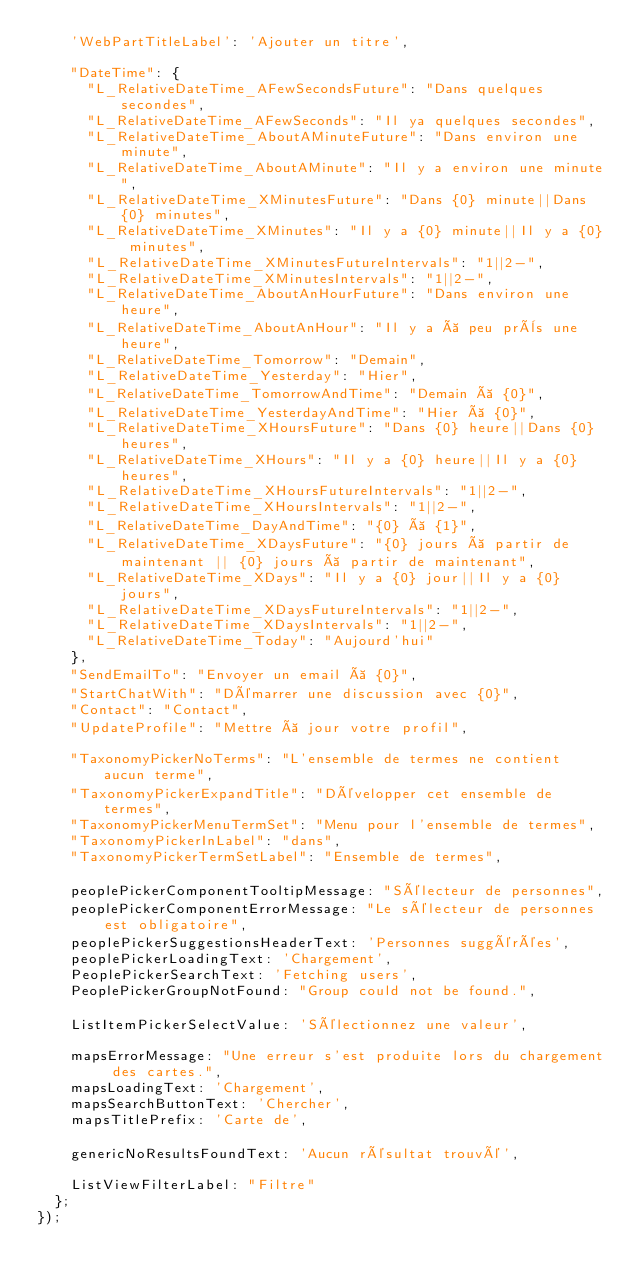<code> <loc_0><loc_0><loc_500><loc_500><_TypeScript_>    'WebPartTitleLabel': 'Ajouter un titre',

    "DateTime": {
      "L_RelativeDateTime_AFewSecondsFuture": "Dans quelques secondes",
      "L_RelativeDateTime_AFewSeconds": "Il ya quelques secondes",
      "L_RelativeDateTime_AboutAMinuteFuture": "Dans environ une minute",
      "L_RelativeDateTime_AboutAMinute": "Il y a environ une minute",
      "L_RelativeDateTime_XMinutesFuture": "Dans {0} minute||Dans {0} minutes",
      "L_RelativeDateTime_XMinutes": "Il y a {0} minute||Il y a {0} minutes",
      "L_RelativeDateTime_XMinutesFutureIntervals": "1||2-",
      "L_RelativeDateTime_XMinutesIntervals": "1||2-",
      "L_RelativeDateTime_AboutAnHourFuture": "Dans environ une heure",
      "L_RelativeDateTime_AboutAnHour": "Il y a à peu près une heure",
      "L_RelativeDateTime_Tomorrow": "Demain",
      "L_RelativeDateTime_Yesterday": "Hier",
      "L_RelativeDateTime_TomorrowAndTime": "Demain à {0}",
      "L_RelativeDateTime_YesterdayAndTime": "Hier à {0}",
      "L_RelativeDateTime_XHoursFuture": "Dans {0} heure||Dans {0} heures",
      "L_RelativeDateTime_XHours": "Il y a {0} heure||Il y a {0} heures",
      "L_RelativeDateTime_XHoursFutureIntervals": "1||2-",
      "L_RelativeDateTime_XHoursIntervals": "1||2-",
      "L_RelativeDateTime_DayAndTime": "{0} à {1}",
      "L_RelativeDateTime_XDaysFuture": "{0} jours à partir de maintenant || {0} jours à partir de maintenant",
      "L_RelativeDateTime_XDays": "Il y a {0} jour||Il y a {0} jours",
      "L_RelativeDateTime_XDaysFutureIntervals": "1||2-",
      "L_RelativeDateTime_XDaysIntervals": "1||2-",
      "L_RelativeDateTime_Today": "Aujourd'hui"
    },
    "SendEmailTo": "Envoyer un email à {0}",
    "StartChatWith": "Démarrer une discussion avec {0}",
    "Contact": "Contact",
    "UpdateProfile": "Mettre à jour votre profil",

    "TaxonomyPickerNoTerms": "L'ensemble de termes ne contient aucun terme",
    "TaxonomyPickerExpandTitle": "Développer cet ensemble de termes",
    "TaxonomyPickerMenuTermSet": "Menu pour l'ensemble de termes",
    "TaxonomyPickerInLabel": "dans",
    "TaxonomyPickerTermSetLabel": "Ensemble de termes",

    peoplePickerComponentTooltipMessage: "Sélecteur de personnes",
    peoplePickerComponentErrorMessage: "Le sélecteur de personnes est obligatoire",
    peoplePickerSuggestionsHeaderText: 'Personnes suggérées',
    peoplePickerLoadingText: 'Chargement',
    PeoplePickerSearchText: 'Fetching users',
    PeoplePickerGroupNotFound: "Group could not be found.",

    ListItemPickerSelectValue: 'Sélectionnez une valeur',

    mapsErrorMessage: "Une erreur s'est produite lors du chargement des cartes.",
    mapsLoadingText: 'Chargement',
    mapsSearchButtonText: 'Chercher',
    mapsTitlePrefix: 'Carte de',

    genericNoResultsFoundText: 'Aucun résultat trouvé',

    ListViewFilterLabel: "Filtre"
  };
});
</code> 